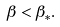Convert formula to latex. <formula><loc_0><loc_0><loc_500><loc_500>\beta < \beta _ { * } .</formula> 